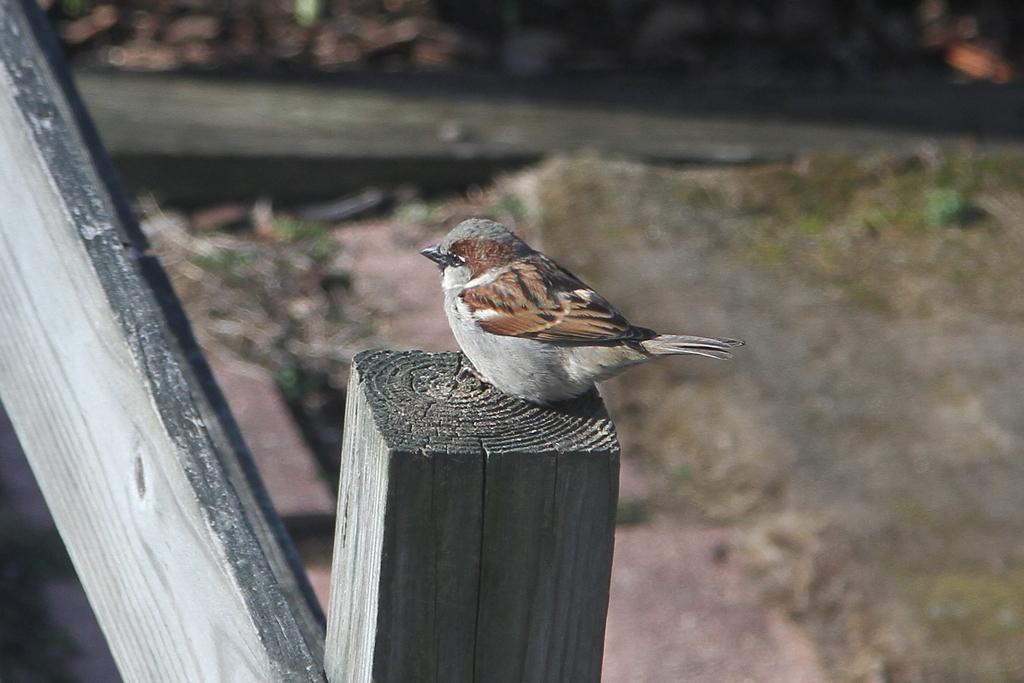Describe this image in one or two sentences. In this image there is a sparrow on a wooden surface, in the background it is blurred. 